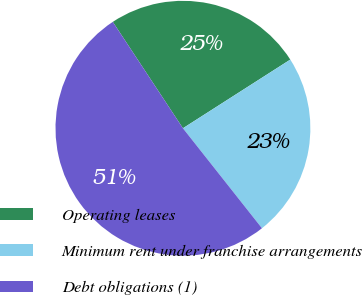<chart> <loc_0><loc_0><loc_500><loc_500><pie_chart><fcel>Operating leases<fcel>Minimum rent under franchise arrangements<fcel>Debt obligations (1)<nl><fcel>25.22%<fcel>23.41%<fcel>51.37%<nl></chart> 